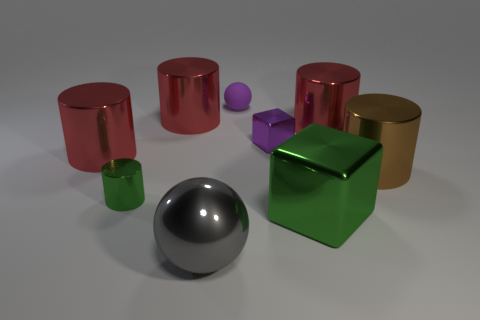Subtract all green cylinders. How many cylinders are left? 4 Add 1 purple objects. How many objects exist? 10 Subtract all purple cubes. How many cubes are left? 1 Subtract all cylinders. How many objects are left? 4 Subtract 1 spheres. How many spheres are left? 1 Subtract all small purple metal objects. Subtract all tiny gray spheres. How many objects are left? 8 Add 6 big red cylinders. How many big red cylinders are left? 9 Add 2 big gray cubes. How many big gray cubes exist? 2 Subtract 1 purple cubes. How many objects are left? 8 Subtract all red balls. Subtract all purple blocks. How many balls are left? 2 